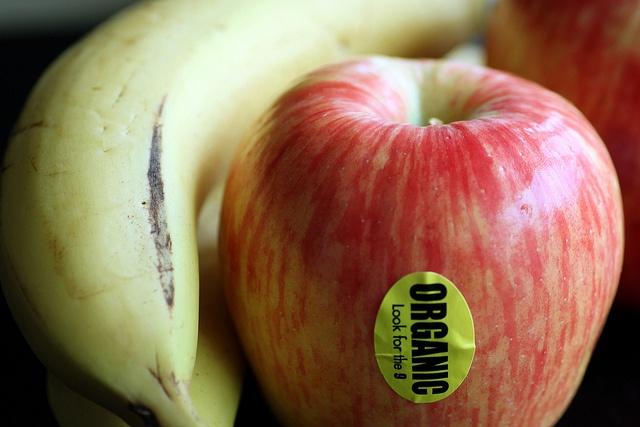Describe the objects in this image and their specific colors. I can see apple in teal, maroon, lightpink, salmon, and brown tones, banana in teal, beige, olive, and black tones, and apple in teal, maroon, and brown tones in this image. 